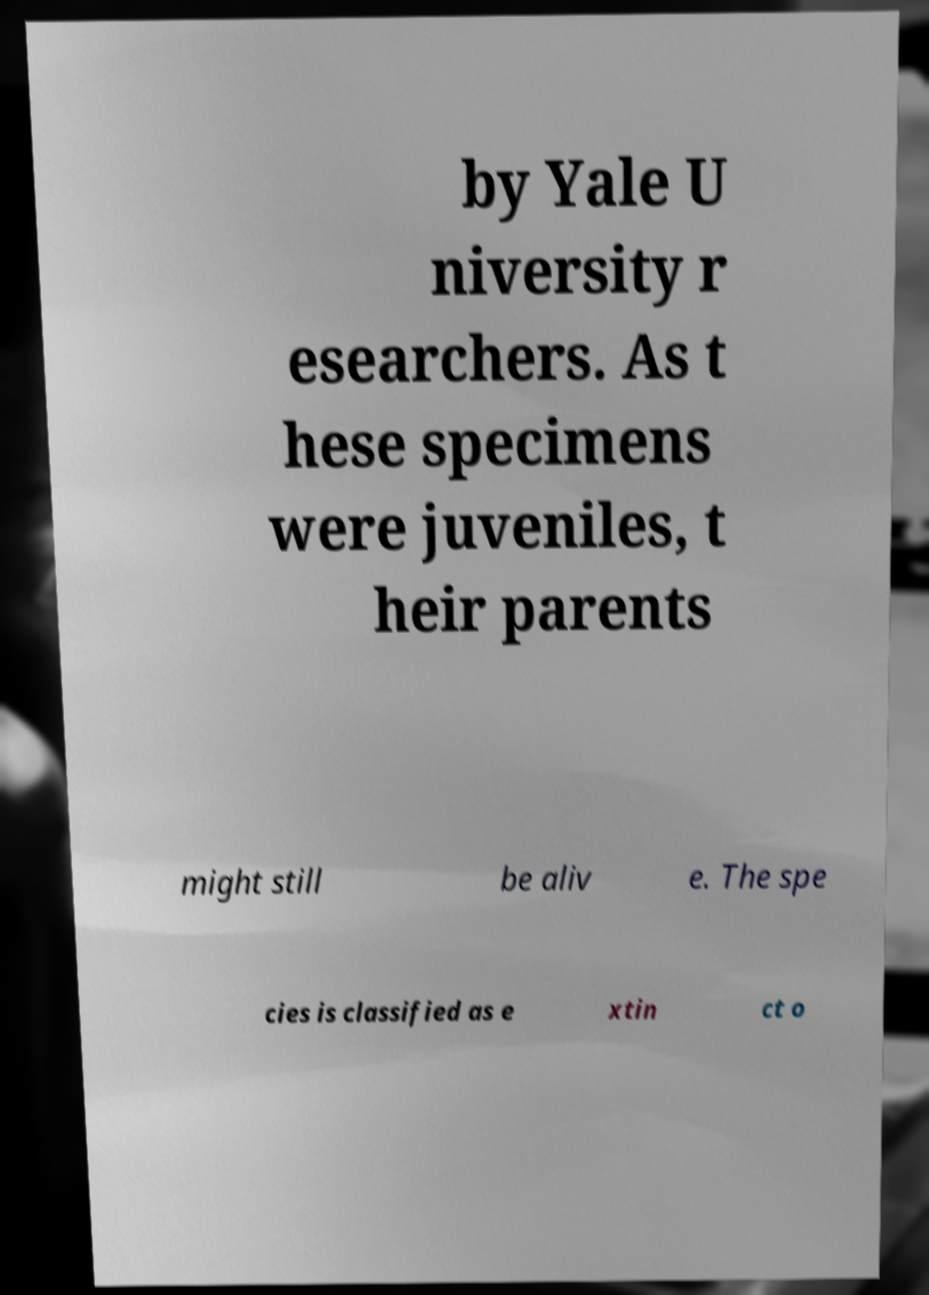Please read and relay the text visible in this image. What does it say? by Yale U niversity r esearchers. As t hese specimens were juveniles, t heir parents might still be aliv e. The spe cies is classified as e xtin ct o 